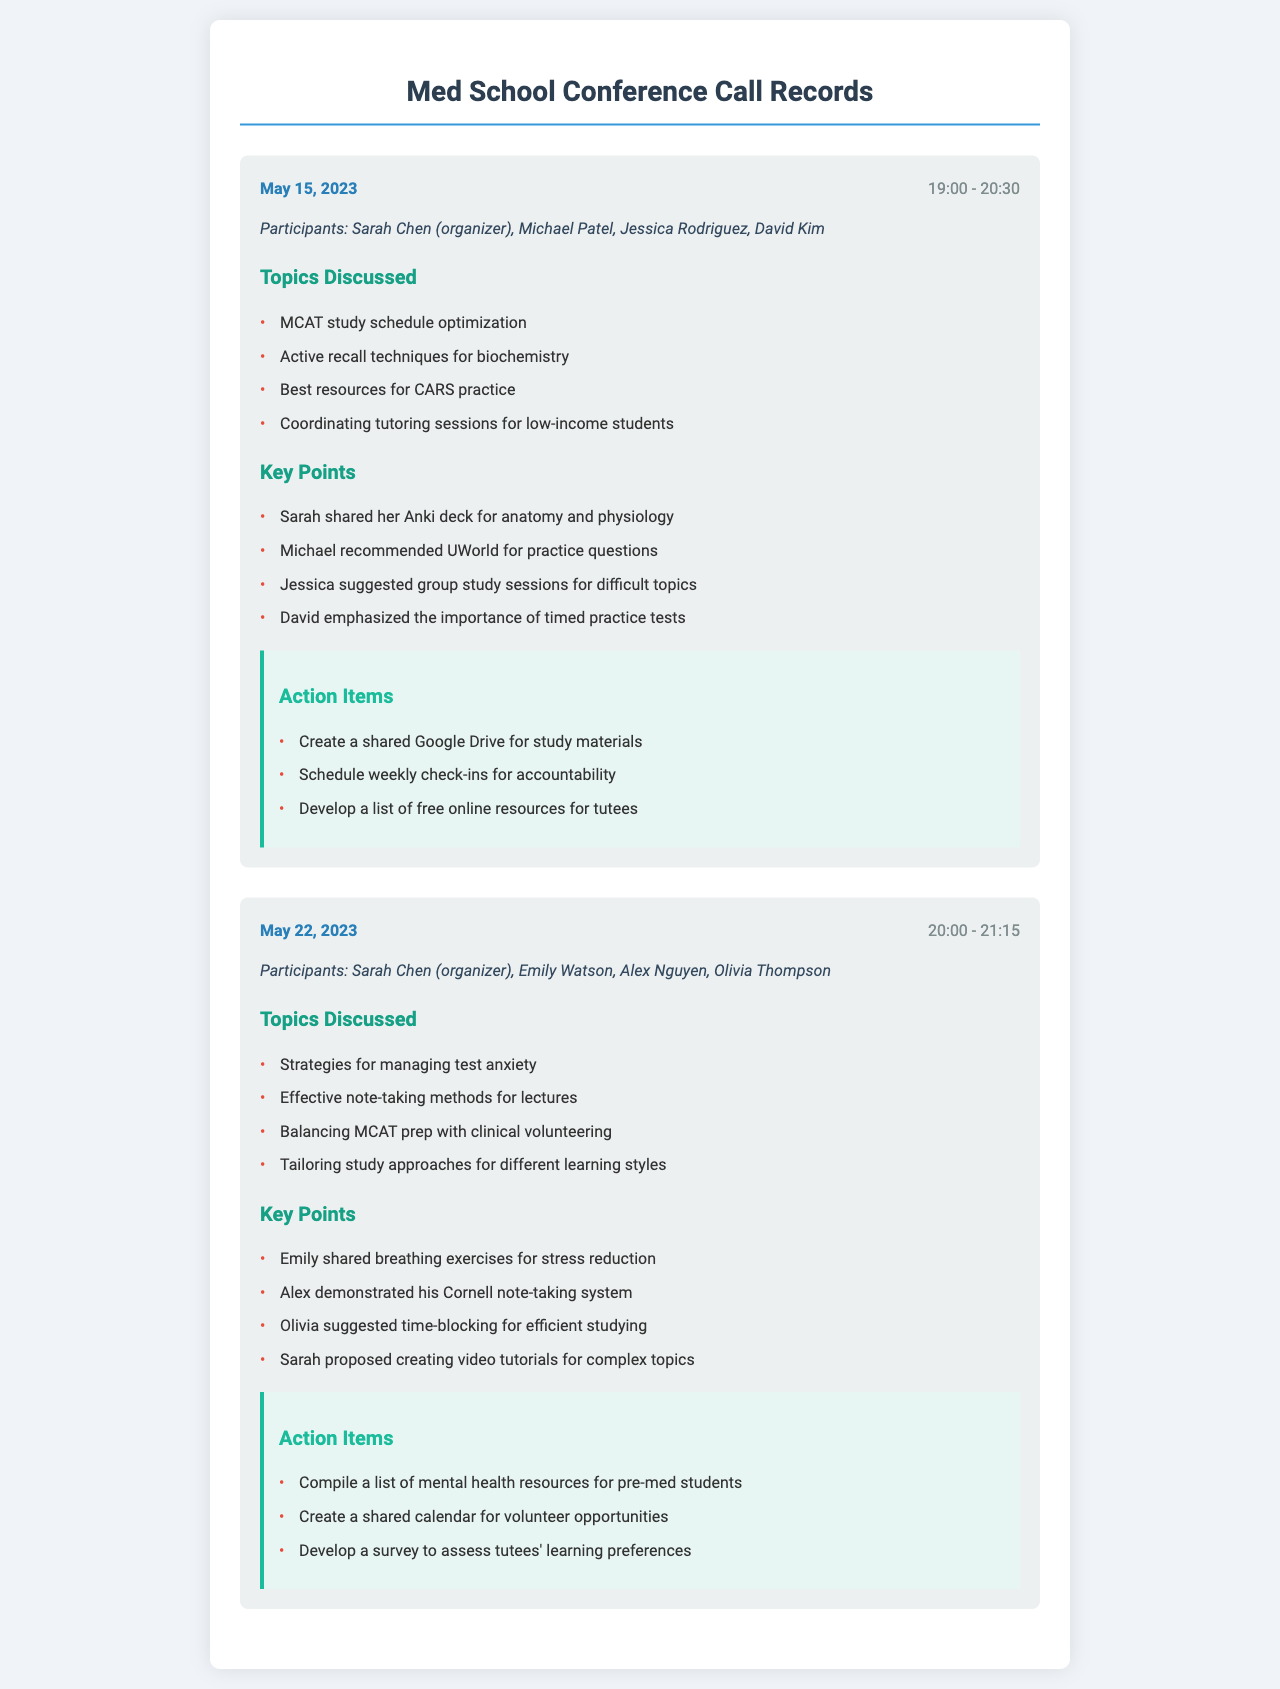What date was the first conference call held? The date of the first conference call can be found in the call record, which is May 15, 2023.
Answer: May 15, 2023 Who was the organizer of the second conference call? The organizer of the second conference call is mentioned in the participants list of that call, which is Sarah Chen.
Answer: Sarah Chen What study resource did Michael recommend? Michael's recommendation can be found in the key points of the first call, where it specifically mentions UWorld for practice questions.
Answer: UWorld How long did the first conference call last? The duration of the first call is indicated by the time frame provided, which is from 19:00 to 20:30, totaling 1 hour and 30 minutes.
Answer: 1 hour and 30 minutes What technique did Emily share for managing stress? The key points in the second call indicate that Emily shared breathing exercises for stress reduction.
Answer: Breathing exercises What is one action item from the second call? The action items section in the second call lists several tasks, one of which is to compile a list of mental health resources for pre-med students.
Answer: Compile a list of mental health resources for pre-med students How many participants were in the first conference call? The number of participants can be derived from the list provided, which includes four names.
Answer: Four Which study technique was emphasized by David? David's emphasis on timed practice tests is noted in the key points of the first call, highlighting its importance.
Answer: Timed practice tests 